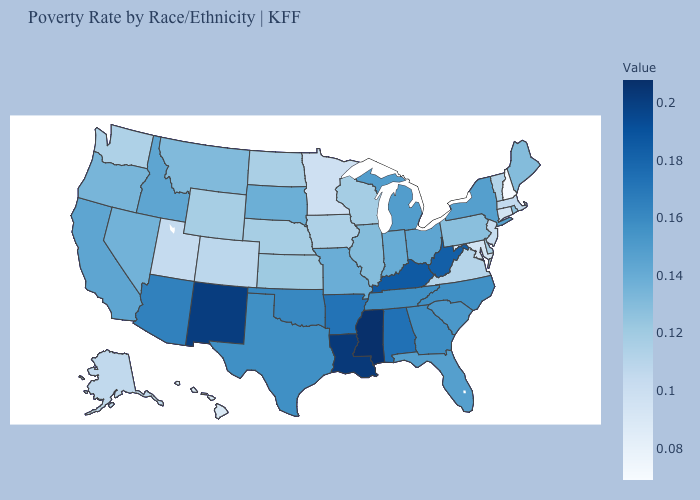Among the states that border Louisiana , does Texas have the lowest value?
Answer briefly. Yes. Which states have the lowest value in the USA?
Concise answer only. New Hampshire. Among the states that border Tennessee , which have the lowest value?
Quick response, please. Virginia. Is the legend a continuous bar?
Give a very brief answer. Yes. Does Illinois have a higher value than Minnesota?
Short answer required. Yes. Does New Hampshire have the lowest value in the Northeast?
Quick response, please. Yes. Among the states that border Kentucky , which have the highest value?
Short answer required. West Virginia. Which states have the highest value in the USA?
Quick response, please. Mississippi. Does Mississippi have the highest value in the USA?
Quick response, please. Yes. 